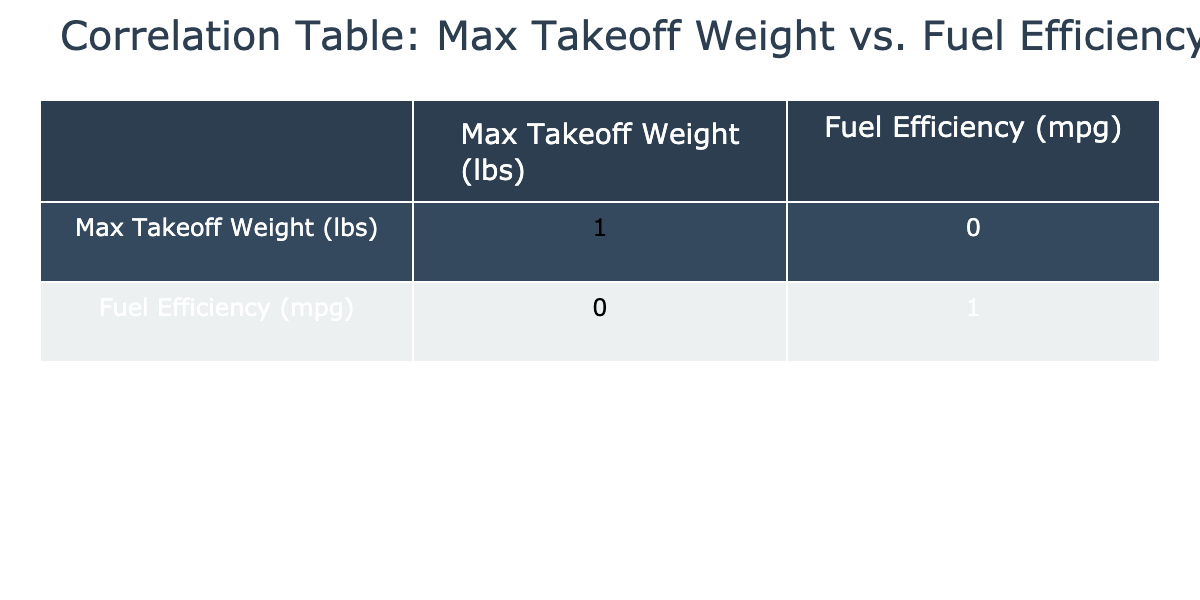What is the fuel efficiency of the Boeing B-17 Flying Fortress? The table shows that the fuel efficiency for the Boeing B-17 Flying Fortress is listed as 2.5 mpg.
Answer: 2.5 mpg Which aircraft has the highest maximum takeoff weight? From the table, the Boeing 747 has the maximum takeoff weight at 98,700 lbs.
Answer: Boeing 747 What is the correlation coefficient between fuel efficiency and max takeoff weight? The correlation coefficient between fuel efficiency and max takeoff weight can be found in the table and is -0.67, indicating a negative correlation.
Answer: -0.67 What is the average fuel efficiency of aircraft that weigh over 40,000 lbs? The aircraft over 40,000 lbs in the table are Boeing B-17 Flying Fortress (2.5 mpg), McDonnell Douglas F-4 Phantom II (4.5 mpg), Consolidated B-24 Liberator (3.8 mpg), and Avro Lancaster (4.0 mpg). Adding these values gives us 2.5 + 4.5 + 3.8 + 4.0 = 15.8 mpg. Now, divide by the 4 aircraft to get an average: 15.8 / 4 = 3.95 mpg.
Answer: 3.95 mpg Is the fuel efficiency of the Douglas DC-3 higher than that of the Curtiss P-40 Warhawk? According to the table, the fuel efficiency of the Douglas DC-3 is 15.0 mpg, while the Curtiss P-40 Warhawk has 6.0 mpg. Since 15.0 is greater than 6.0, the answer is yes.
Answer: Yes Which aircraft has the lowest fuel efficiency? The table indicates that the aircraft with the lowest fuel efficiency is the Boeing B-17 Flying Fortress with a fuel efficiency of 2.5 mpg.
Answer: Boeing B-17 Flying Fortress Do any aircraft have the same fuel efficiency? Looking at the table, we can see that there are no duplicate fuel efficiency values among the listed aircraft; each value is unique.
Answer: No What is the difference in fuel efficiency between the Lockheed P-38 Lightning and the Boeing 747? The Lockheed P-38 Lightning has a fuel efficiency of 5.3 mpg and the Boeing 747 has 12.0 mpg. The difference is 12.0 - 5.3 = 6.7 mpg.
Answer: 6.7 mpg 